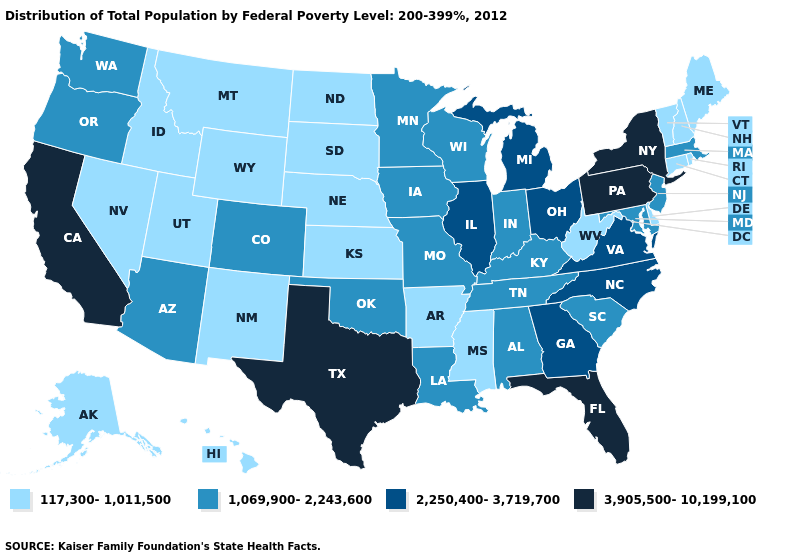What is the value of Maryland?
Concise answer only. 1,069,900-2,243,600. Does the map have missing data?
Give a very brief answer. No. What is the value of New Hampshire?
Give a very brief answer. 117,300-1,011,500. Name the states that have a value in the range 2,250,400-3,719,700?
Quick response, please. Georgia, Illinois, Michigan, North Carolina, Ohio, Virginia. Among the states that border Mississippi , which have the lowest value?
Concise answer only. Arkansas. Among the states that border Wyoming , which have the highest value?
Quick response, please. Colorado. What is the value of Hawaii?
Write a very short answer. 117,300-1,011,500. What is the highest value in the Northeast ?
Quick response, please. 3,905,500-10,199,100. Does Pennsylvania have the highest value in the USA?
Be succinct. Yes. Among the states that border Washington , which have the highest value?
Write a very short answer. Oregon. What is the value of Illinois?
Give a very brief answer. 2,250,400-3,719,700. What is the value of Illinois?
Give a very brief answer. 2,250,400-3,719,700. What is the highest value in the USA?
Keep it brief. 3,905,500-10,199,100. What is the value of New York?
Be succinct. 3,905,500-10,199,100. Does the first symbol in the legend represent the smallest category?
Concise answer only. Yes. 